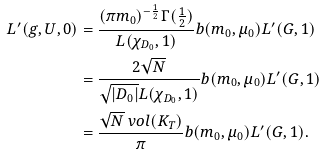Convert formula to latex. <formula><loc_0><loc_0><loc_500><loc_500>L ^ { \prime } ( g , U , 0 ) & = \frac { ( \pi m _ { 0 } ) ^ { - \frac { 1 } 2 } \Gamma ( \frac { 1 } 2 ) } { L ( \chi _ { D _ { 0 } } , 1 ) } b ( m _ { 0 } , \mu _ { 0 } ) L ^ { \prime } ( G , 1 ) \\ & = \frac { 2 \sqrt { N } } { \sqrt { | D _ { 0 } | } L ( \chi _ { D _ { 0 } } , 1 ) } b ( m _ { 0 } , \mu _ { 0 } ) L ^ { \prime } ( G , 1 ) \\ & = \frac { \sqrt { N } \ v o l ( K _ { T } ) } { \pi } b ( m _ { 0 } , \mu _ { 0 } ) L ^ { \prime } ( G , 1 ) .</formula> 